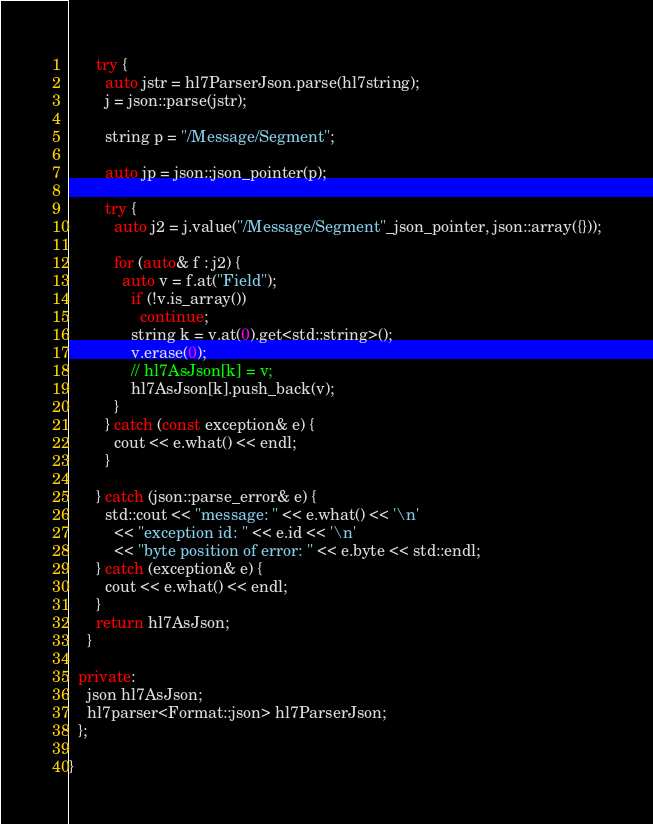<code> <loc_0><loc_0><loc_500><loc_500><_C++_>      try {
        auto jstr = hl7ParserJson.parse(hl7string);
        j = json::parse(jstr);

        string p = "/Message/Segment";
        
        auto jp = json::json_pointer(p);

        try {
          auto j2 = j.value("/Message/Segment"_json_pointer, json::array({}));

          for (auto& f : j2) {
            auto v = f.at("Field");
              if (!v.is_array())
                continue;
              string k = v.at(0).get<std::string>();
              v.erase(0);
              // hl7AsJson[k] = v;
              hl7AsJson[k].push_back(v);
          }
        } catch (const exception& e) {
          cout << e.what() << endl;
        }

      } catch (json::parse_error& e) {
        std::cout << "message: " << e.what() << '\n'
          << "exception id: " << e.id << '\n'
          << "byte position of error: " << e.byte << std::endl;
      } catch (exception& e) {
        cout << e.what() << endl;
      }
      return hl7AsJson;
    }

  private:
    json hl7AsJson;  
    hl7parser<Format::json> hl7ParserJson;
  };

}

</code> 